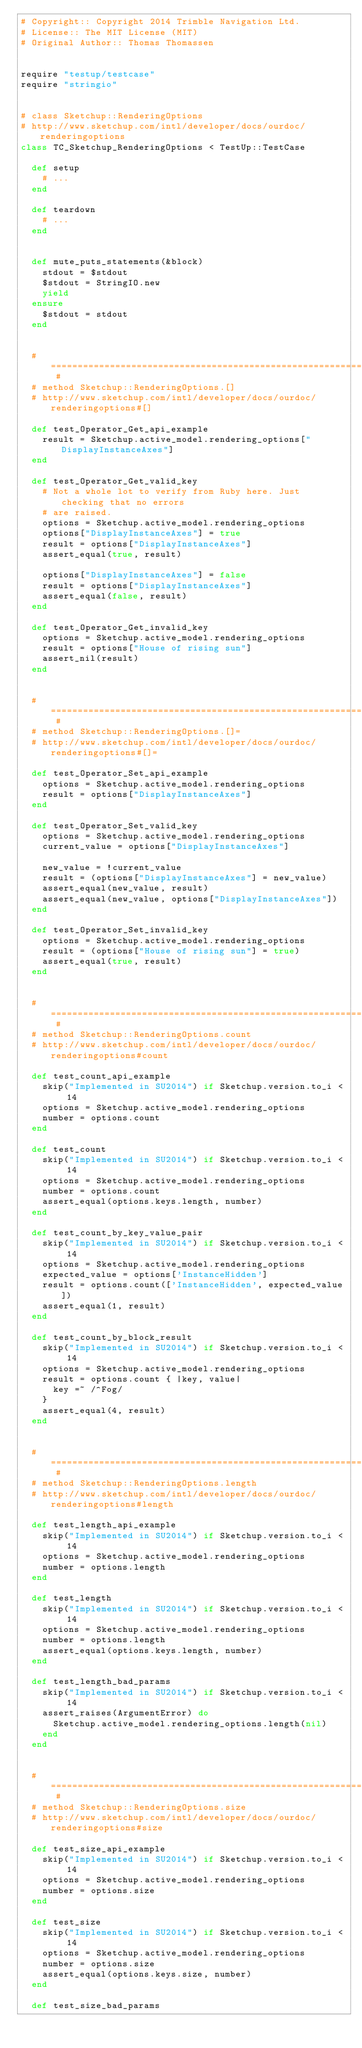Convert code to text. <code><loc_0><loc_0><loc_500><loc_500><_Ruby_># Copyright:: Copyright 2014 Trimble Navigation Ltd.
# License:: The MIT License (MIT)
# Original Author:: Thomas Thomassen


require "testup/testcase"
require "stringio"


# class Sketchup::RenderingOptions
# http://www.sketchup.com/intl/developer/docs/ourdoc/renderingoptions
class TC_Sketchup_RenderingOptions < TestUp::TestCase

  def setup
    # ...
  end

  def teardown
    # ...
  end


  def mute_puts_statements(&block)
    stdout = $stdout
    $stdout = StringIO.new
    yield
  ensure
    $stdout = stdout
  end


  # ========================================================================== #
  # method Sketchup::RenderingOptions.[]
  # http://www.sketchup.com/intl/developer/docs/ourdoc/renderingoptions#[]

  def test_Operator_Get_api_example
    result = Sketchup.active_model.rendering_options["DisplayInstanceAxes"]
  end

  def test_Operator_Get_valid_key
    # Not a whole lot to verify from Ruby here. Just checking that no errors
    # are raised.
    options = Sketchup.active_model.rendering_options
    options["DisplayInstanceAxes"] = true
    result = options["DisplayInstanceAxes"]
    assert_equal(true, result)

    options["DisplayInstanceAxes"] = false
    result = options["DisplayInstanceAxes"]
    assert_equal(false, result)
  end

  def test_Operator_Get_invalid_key
    options = Sketchup.active_model.rendering_options
    result = options["House of rising sun"]
    assert_nil(result)
  end


  # ========================================================================== #
  # method Sketchup::RenderingOptions.[]=
  # http://www.sketchup.com/intl/developer/docs/ourdoc/renderingoptions#[]=

  def test_Operator_Set_api_example
    options = Sketchup.active_model.rendering_options
    result = options["DisplayInstanceAxes"]
  end

  def test_Operator_Set_valid_key
    options = Sketchup.active_model.rendering_options
    current_value = options["DisplayInstanceAxes"]

    new_value = !current_value
    result = (options["DisplayInstanceAxes"] = new_value)
    assert_equal(new_value, result)
    assert_equal(new_value, options["DisplayInstanceAxes"])
  end

  def test_Operator_Set_invalid_key
    options = Sketchup.active_model.rendering_options
    result = (options["House of rising sun"] = true)
    assert_equal(true, result)
  end


  # ========================================================================== #
  # method Sketchup::RenderingOptions.count
  # http://www.sketchup.com/intl/developer/docs/ourdoc/renderingoptions#count

  def test_count_api_example
    skip("Implemented in SU2014") if Sketchup.version.to_i < 14
    options = Sketchup.active_model.rendering_options
    number = options.count
  end

  def test_count
    skip("Implemented in SU2014") if Sketchup.version.to_i < 14
    options = Sketchup.active_model.rendering_options
    number = options.count
    assert_equal(options.keys.length, number)
  end

  def test_count_by_key_value_pair
    skip("Implemented in SU2014") if Sketchup.version.to_i < 14
    options = Sketchup.active_model.rendering_options
    expected_value = options['InstanceHidden']
    result = options.count(['InstanceHidden', expected_value])
    assert_equal(1, result)
  end

  def test_count_by_block_result
    skip("Implemented in SU2014") if Sketchup.version.to_i < 14
    options = Sketchup.active_model.rendering_options
    result = options.count { |key, value|
      key =~ /^Fog/
    }
    assert_equal(4, result)
  end


  # ========================================================================== #
  # method Sketchup::RenderingOptions.length
  # http://www.sketchup.com/intl/developer/docs/ourdoc/renderingoptions#length

  def test_length_api_example
    skip("Implemented in SU2014") if Sketchup.version.to_i < 14
    options = Sketchup.active_model.rendering_options
    number = options.length
  end

  def test_length
    skip("Implemented in SU2014") if Sketchup.version.to_i < 14
    options = Sketchup.active_model.rendering_options
    number = options.length
    assert_equal(options.keys.length, number)
  end

  def test_length_bad_params
    skip("Implemented in SU2014") if Sketchup.version.to_i < 14
    assert_raises(ArgumentError) do
      Sketchup.active_model.rendering_options.length(nil)
    end
  end


  # ========================================================================== #
  # method Sketchup::RenderingOptions.size
  # http://www.sketchup.com/intl/developer/docs/ourdoc/renderingoptions#size

  def test_size_api_example
    skip("Implemented in SU2014") if Sketchup.version.to_i < 14
    options = Sketchup.active_model.rendering_options
    number = options.size
  end

  def test_size
    skip("Implemented in SU2014") if Sketchup.version.to_i < 14
    options = Sketchup.active_model.rendering_options
    number = options.size
    assert_equal(options.keys.size, number)
  end

  def test_size_bad_params</code> 